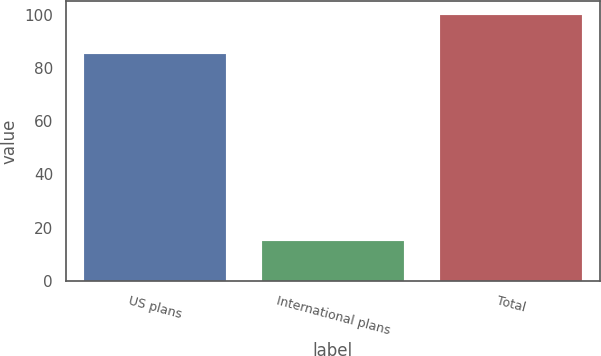Convert chart to OTSL. <chart><loc_0><loc_0><loc_500><loc_500><bar_chart><fcel>US plans<fcel>International plans<fcel>Total<nl><fcel>85<fcel>15<fcel>100<nl></chart> 